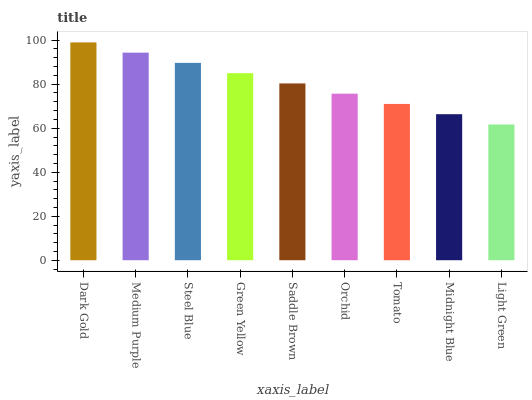Is Light Green the minimum?
Answer yes or no. Yes. Is Dark Gold the maximum?
Answer yes or no. Yes. Is Medium Purple the minimum?
Answer yes or no. No. Is Medium Purple the maximum?
Answer yes or no. No. Is Dark Gold greater than Medium Purple?
Answer yes or no. Yes. Is Medium Purple less than Dark Gold?
Answer yes or no. Yes. Is Medium Purple greater than Dark Gold?
Answer yes or no. No. Is Dark Gold less than Medium Purple?
Answer yes or no. No. Is Saddle Brown the high median?
Answer yes or no. Yes. Is Saddle Brown the low median?
Answer yes or no. Yes. Is Dark Gold the high median?
Answer yes or no. No. Is Dark Gold the low median?
Answer yes or no. No. 